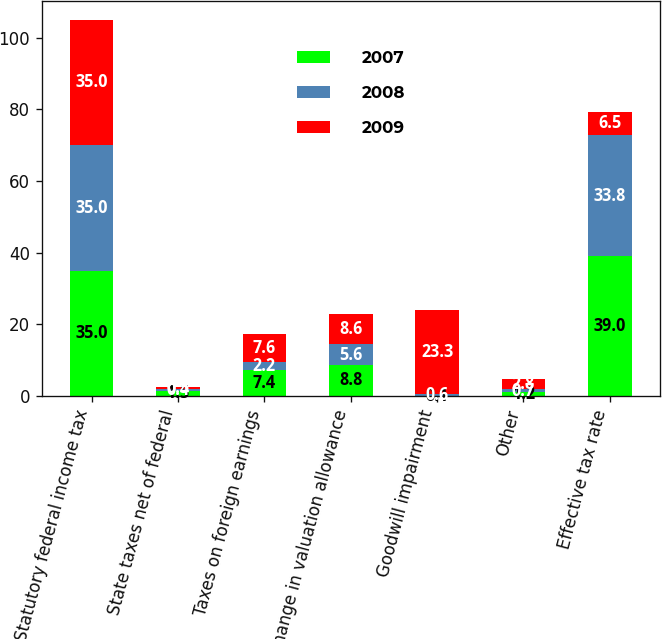Convert chart to OTSL. <chart><loc_0><loc_0><loc_500><loc_500><stacked_bar_chart><ecel><fcel>Statutory federal income tax<fcel>State taxes net of federal<fcel>Taxes on foreign earnings<fcel>Change in valuation allowance<fcel>Goodwill impairment<fcel>Other<fcel>Effective tax rate<nl><fcel>2007<fcel>35<fcel>1.5<fcel>7.4<fcel>8.8<fcel>0.1<fcel>1.2<fcel>39<nl><fcel>2008<fcel>35<fcel>0.4<fcel>2.2<fcel>5.6<fcel>0.6<fcel>0.7<fcel>33.8<nl><fcel>2009<fcel>35<fcel>0.5<fcel>7.6<fcel>8.6<fcel>23.3<fcel>2.8<fcel>6.5<nl></chart> 